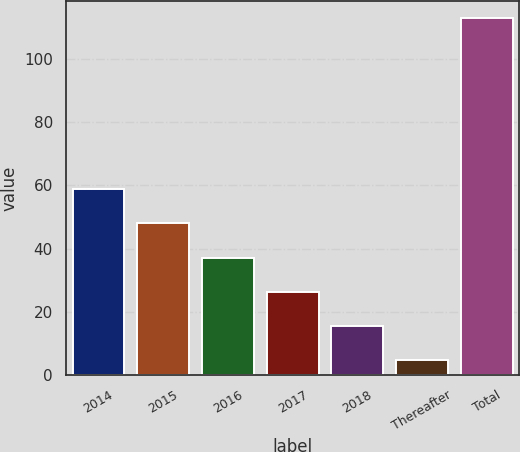Convert chart. <chart><loc_0><loc_0><loc_500><loc_500><bar_chart><fcel>2014<fcel>2015<fcel>2016<fcel>2017<fcel>2018<fcel>Thereafter<fcel>Total<nl><fcel>58.75<fcel>47.96<fcel>37.17<fcel>26.38<fcel>15.59<fcel>4.8<fcel>112.7<nl></chart> 